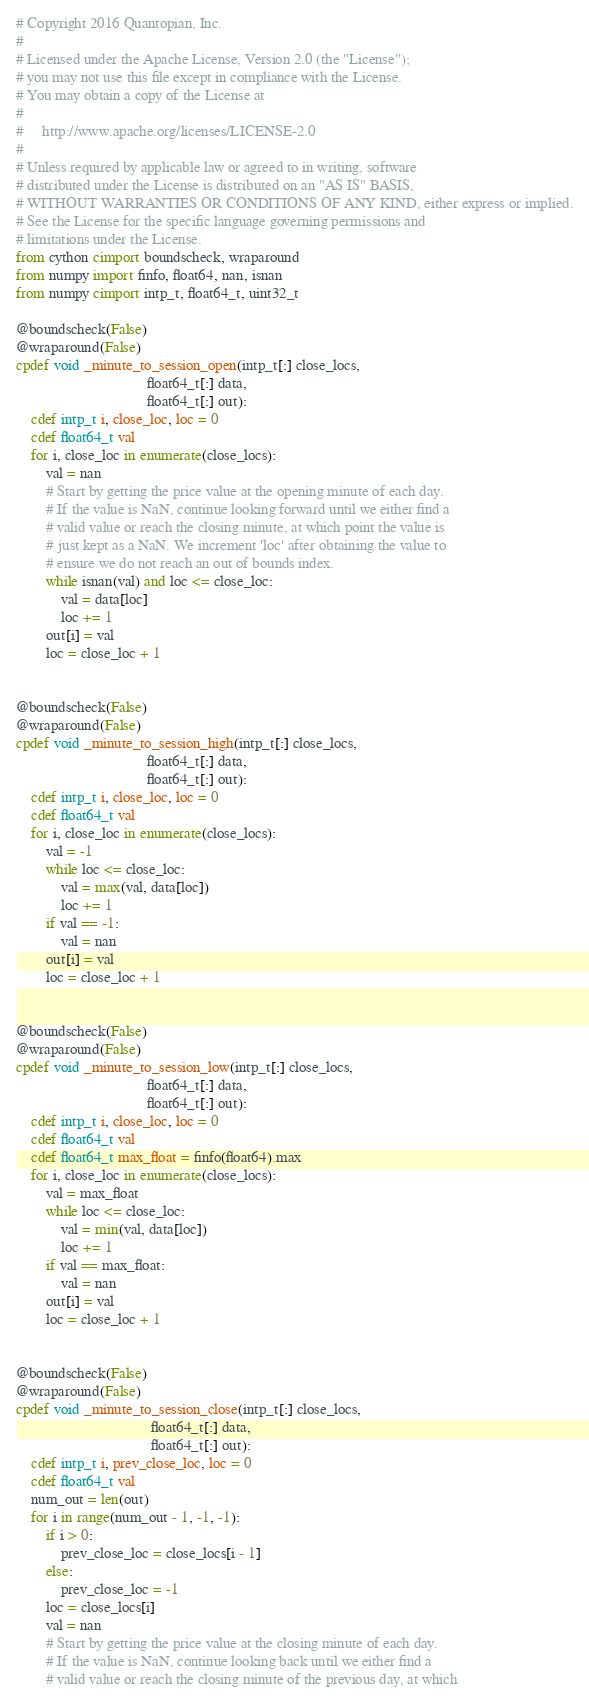<code> <loc_0><loc_0><loc_500><loc_500><_Cython_># Copyright 2016 Quantopian, Inc.
#
# Licensed under the Apache License, Version 2.0 (the "License");
# you may not use this file except in compliance with the License.
# You may obtain a copy of the License at
#
#     http://www.apache.org/licenses/LICENSE-2.0
#
# Unless required by applicable law or agreed to in writing, software
# distributed under the License is distributed on an "AS IS" BASIS,
# WITHOUT WARRANTIES OR CONDITIONS OF ANY KIND, either express or implied.
# See the License for the specific language governing permissions and
# limitations under the License.
from cython cimport boundscheck, wraparound
from numpy import finfo, float64, nan, isnan
from numpy cimport intp_t, float64_t, uint32_t

@boundscheck(False)
@wraparound(False)
cpdef void _minute_to_session_open(intp_t[:] close_locs,
                                   float64_t[:] data,
                                   float64_t[:] out):
    cdef intp_t i, close_loc, loc = 0
    cdef float64_t val
    for i, close_loc in enumerate(close_locs):
        val = nan
        # Start by getting the price value at the opening minute of each day.
        # If the value is NaN, continue looking forward until we either find a
        # valid value or reach the closing minute, at which point the value is
        # just kept as a NaN. We increment 'loc' after obtaining the value to
        # ensure we do not reach an out of bounds index.
        while isnan(val) and loc <= close_loc:
            val = data[loc]
            loc += 1
        out[i] = val
        loc = close_loc + 1


@boundscheck(False)
@wraparound(False)
cpdef void _minute_to_session_high(intp_t[:] close_locs,
                                   float64_t[:] data,
                                   float64_t[:] out):
    cdef intp_t i, close_loc, loc = 0
    cdef float64_t val
    for i, close_loc in enumerate(close_locs):
        val = -1
        while loc <= close_loc:
            val = max(val, data[loc])
            loc += 1
        if val == -1:
            val = nan
        out[i] = val
        loc = close_loc + 1


@boundscheck(False)
@wraparound(False)
cpdef void _minute_to_session_low(intp_t[:] close_locs,
                                   float64_t[:] data,
                                   float64_t[:] out):
    cdef intp_t i, close_loc, loc = 0
    cdef float64_t val
    cdef float64_t max_float = finfo(float64).max
    for i, close_loc in enumerate(close_locs):
        val = max_float
        while loc <= close_loc:
            val = min(val, data[loc])
            loc += 1
        if val == max_float:
            val = nan
        out[i] = val
        loc = close_loc + 1


@boundscheck(False)
@wraparound(False)
cpdef void _minute_to_session_close(intp_t[:] close_locs,
                                    float64_t[:] data,
                                    float64_t[:] out):
    cdef intp_t i, prev_close_loc, loc = 0
    cdef float64_t val
    num_out = len(out)
    for i in range(num_out - 1, -1, -1):
        if i > 0:
            prev_close_loc = close_locs[i - 1]
        else:
            prev_close_loc = -1
        loc = close_locs[i]
        val = nan
        # Start by getting the price value at the closing minute of each day.
        # If the value is NaN, continue looking back until we either find a
        # valid value or reach the closing minute of the previous day, at which</code> 